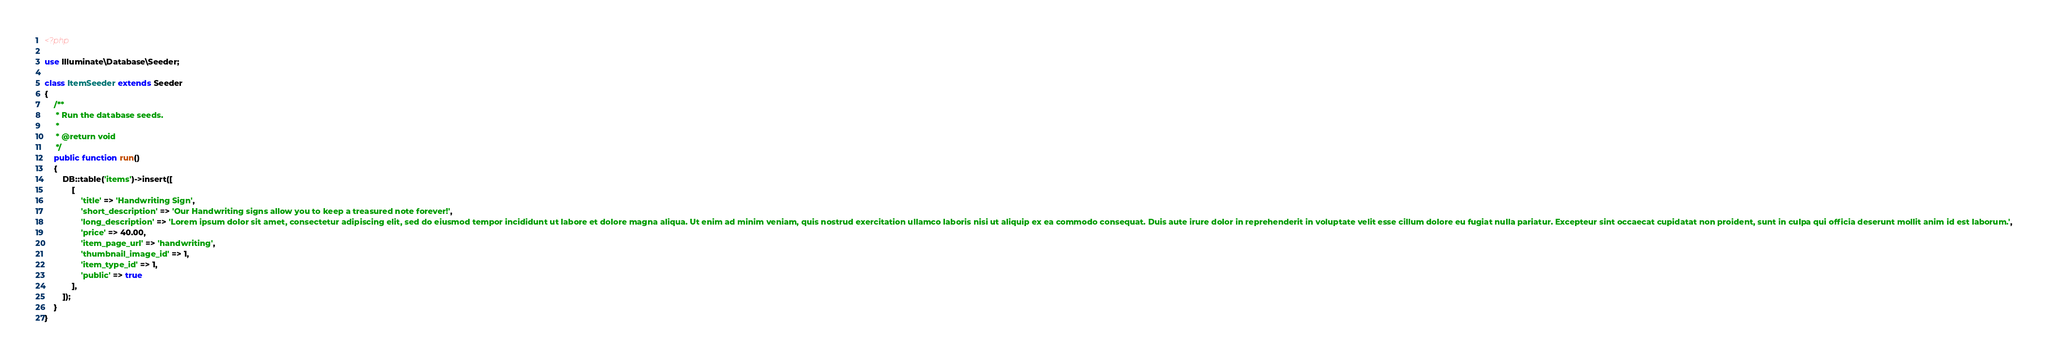Convert code to text. <code><loc_0><loc_0><loc_500><loc_500><_PHP_><?php

use Illuminate\Database\Seeder;

class ItemSeeder extends Seeder
{
    /**
     * Run the database seeds.
     *
     * @return void
     */
    public function run()
    {
        DB::table('items')->insert([
            [
                'title' => 'Handwriting Sign',
                'short_description' => 'Our Handwriting signs allow you to keep a treasured note forever!',
                'long_description' => 'Lorem ipsum dolor sit amet, consectetur adipiscing elit, sed do eiusmod tempor incididunt ut labore et dolore magna aliqua. Ut enim ad minim veniam, quis nostrud exercitation ullamco laboris nisi ut aliquip ex ea commodo consequat. Duis aute irure dolor in reprehenderit in voluptate velit esse cillum dolore eu fugiat nulla pariatur. Excepteur sint occaecat cupidatat non proident, sunt in culpa qui officia deserunt mollit anim id est laborum.',
                'price' => 40.00,
                'item_page_url' => 'handwriting',
                'thumbnail_image_id' => 1,
                'item_type_id' => 1,
                'public' => true
            ],
        ]);
    }
}
</code> 